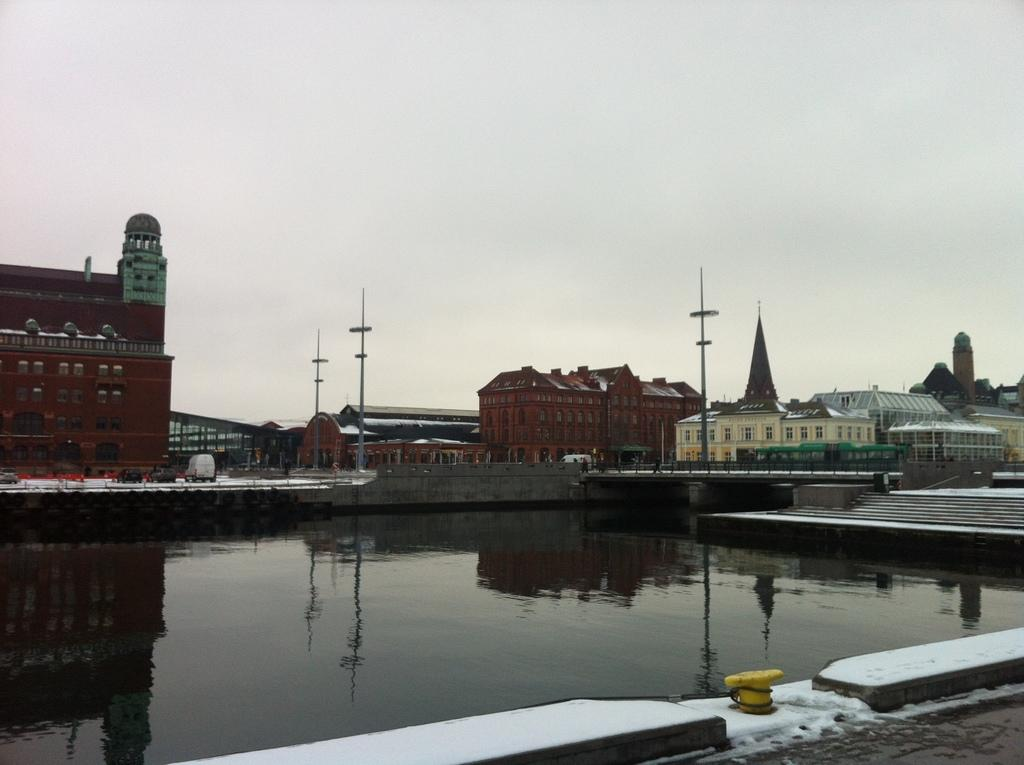What is the primary element visible in the image? There is water in the image. What can be seen in the distance behind the water? There are buildings in the background of the image. What is visible at the top of the image? The sky is visible at the top of the image. How does the coach fly in the image? There is no coach present in the image, so it cannot fly or be observed. 